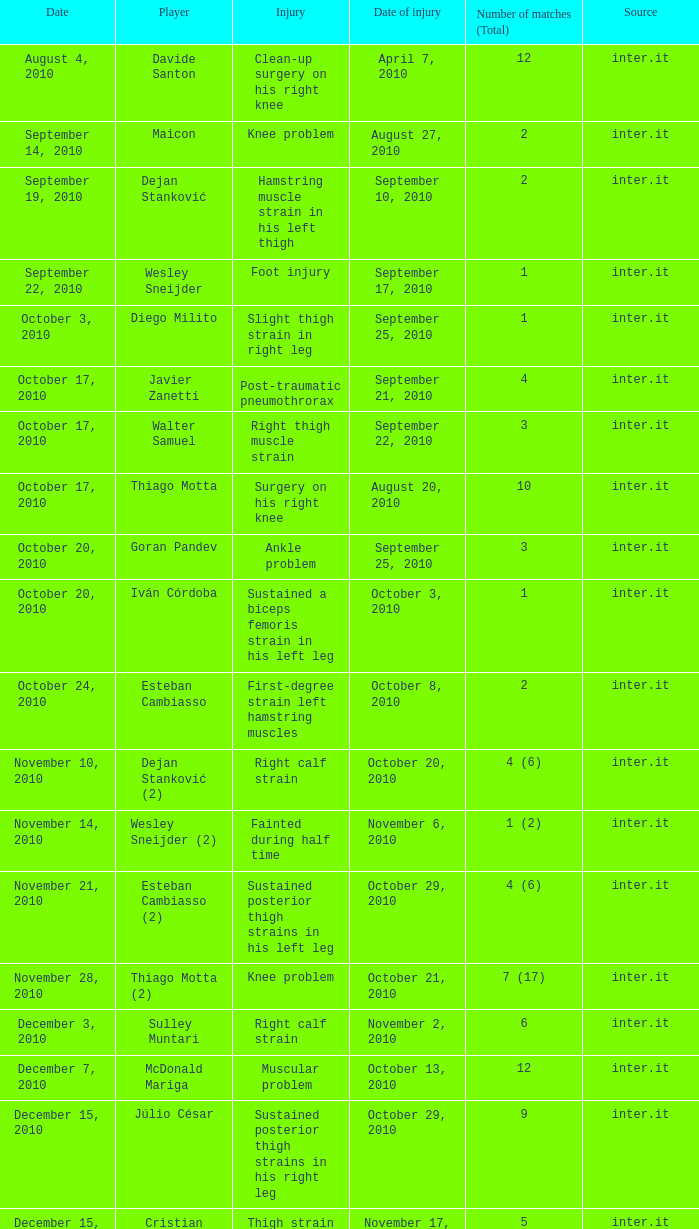What is the date of injury when the injury is foot injury and the number of matches (total) is 1? September 17, 2010. 